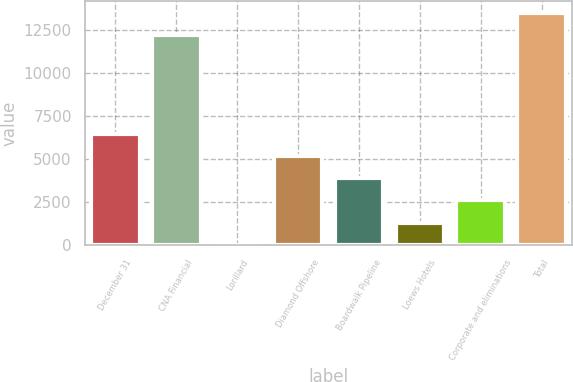Convert chart. <chart><loc_0><loc_0><loc_500><loc_500><bar_chart><fcel>December 31<fcel>CNA Financial<fcel>Lorillard<fcel>Diamond Offshore<fcel>Boardwalk Pipeline<fcel>Loews Hotels<fcel>Corporate and eliminations<fcel>Total<nl><fcel>6476<fcel>12202<fcel>16<fcel>5184<fcel>3892<fcel>1308<fcel>2600<fcel>13494<nl></chart> 